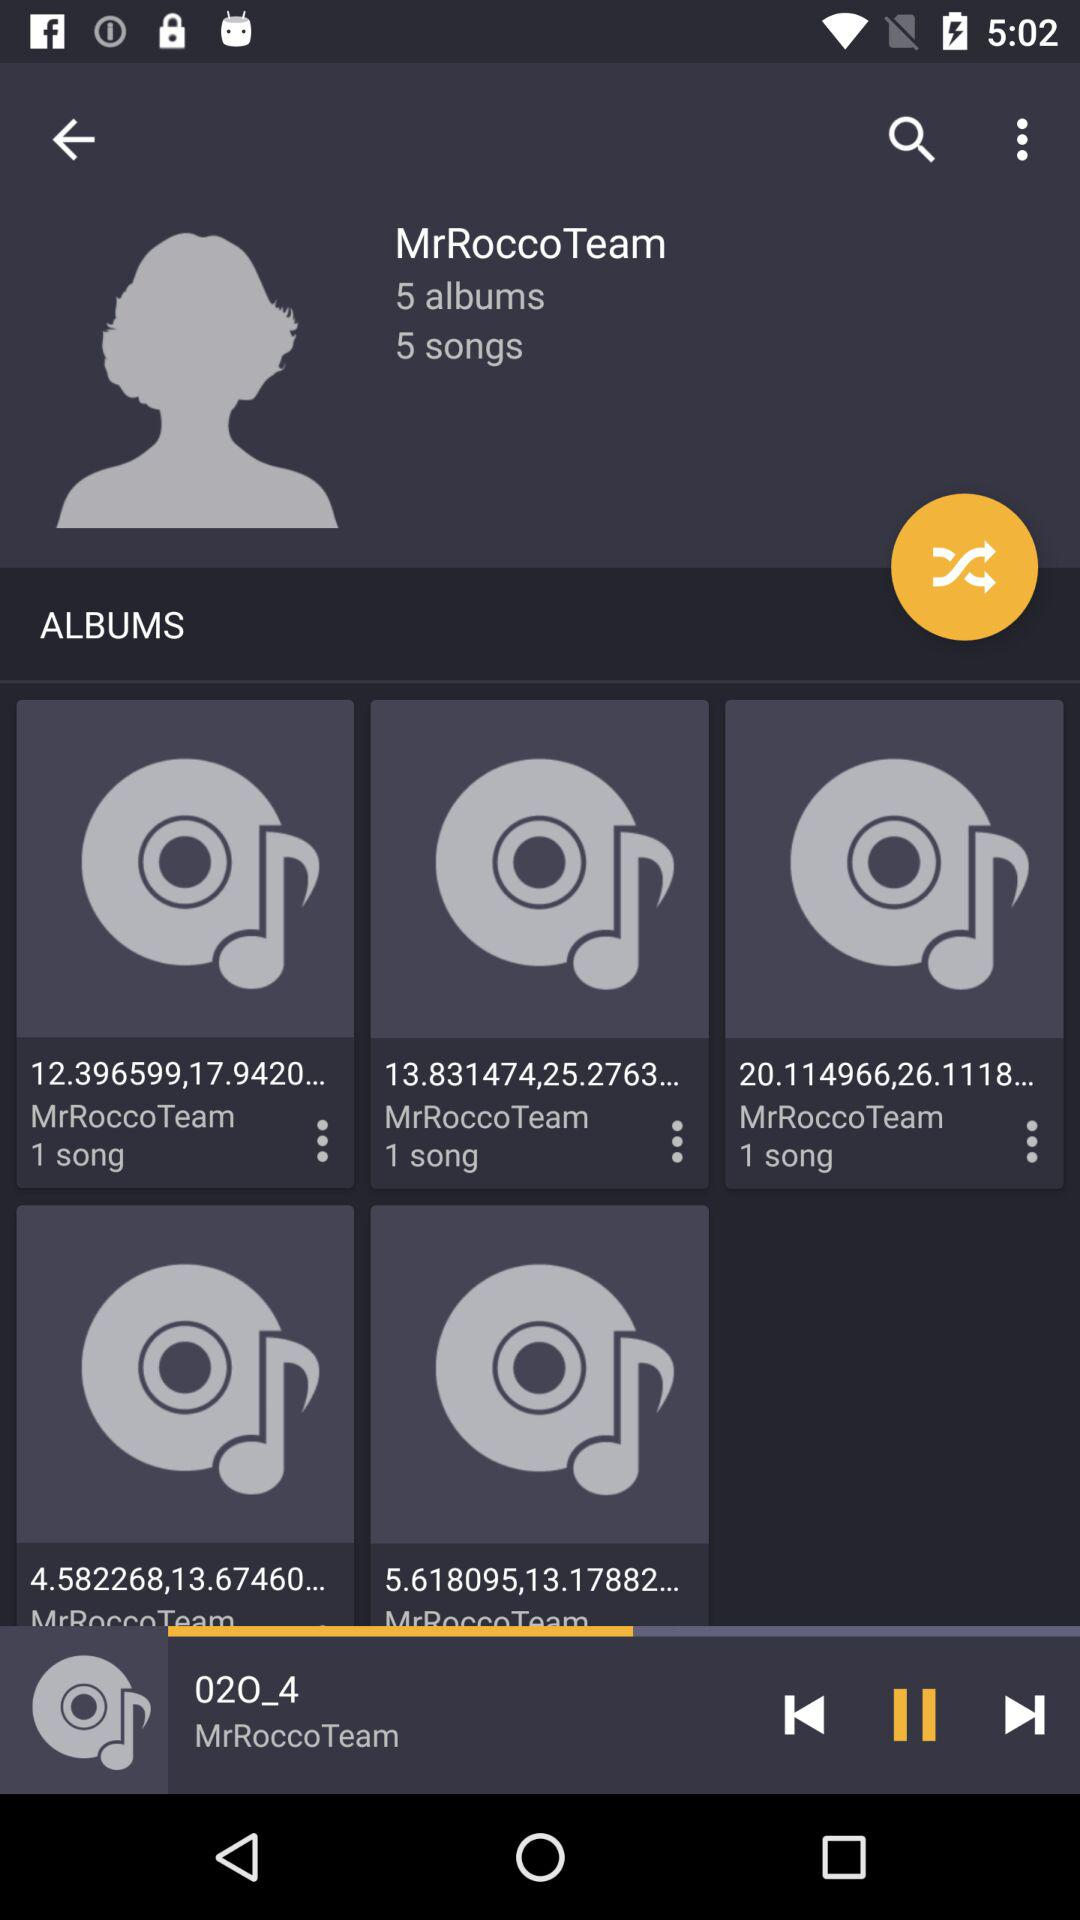Which song is playing? The song that is playing is 020_4. 